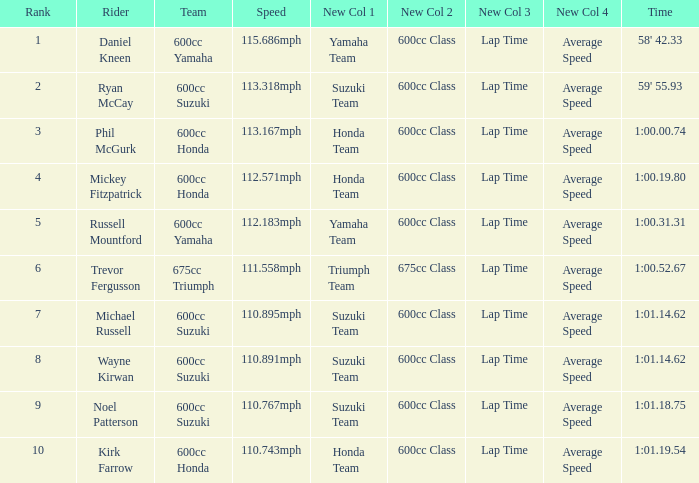What time has phil mcgurk as the rider? 1:00.00.74. 